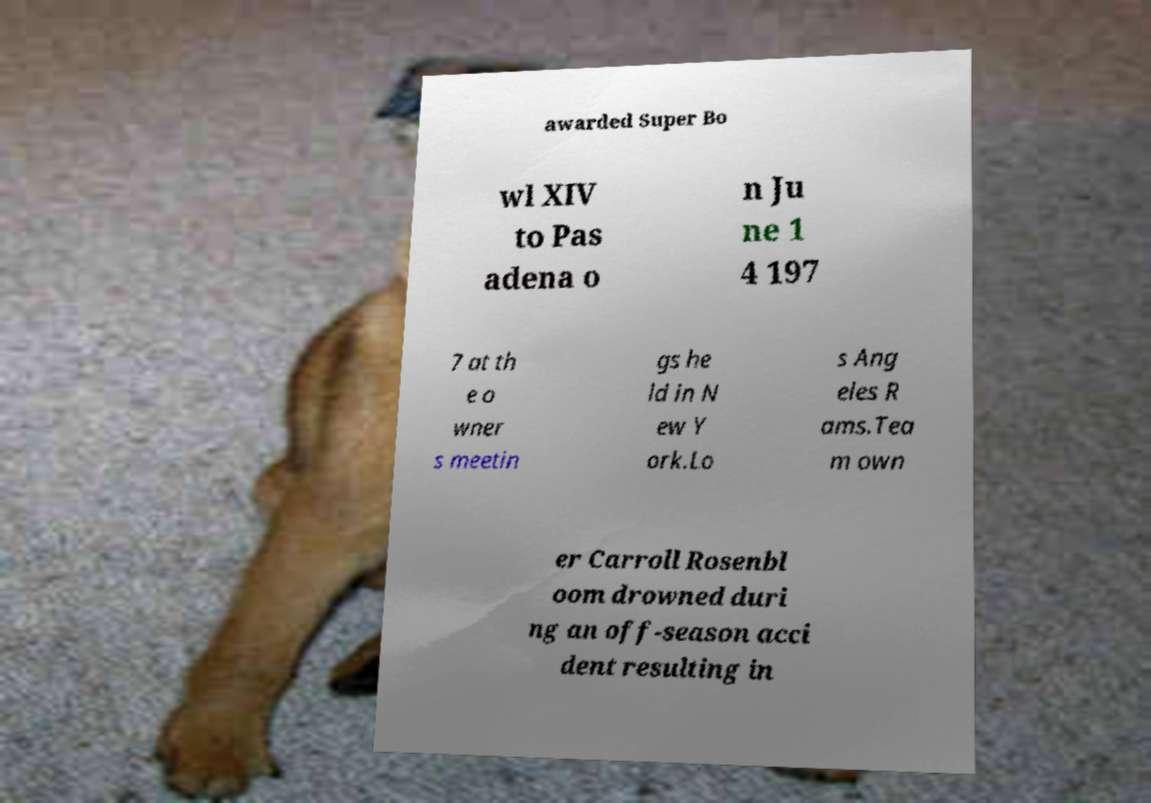Please read and relay the text visible in this image. What does it say? awarded Super Bo wl XIV to Pas adena o n Ju ne 1 4 197 7 at th e o wner s meetin gs he ld in N ew Y ork.Lo s Ang eles R ams.Tea m own er Carroll Rosenbl oom drowned duri ng an off-season acci dent resulting in 